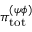<formula> <loc_0><loc_0><loc_500><loc_500>{ \pi } _ { t o t } ^ { ( \psi \phi ) }</formula> 